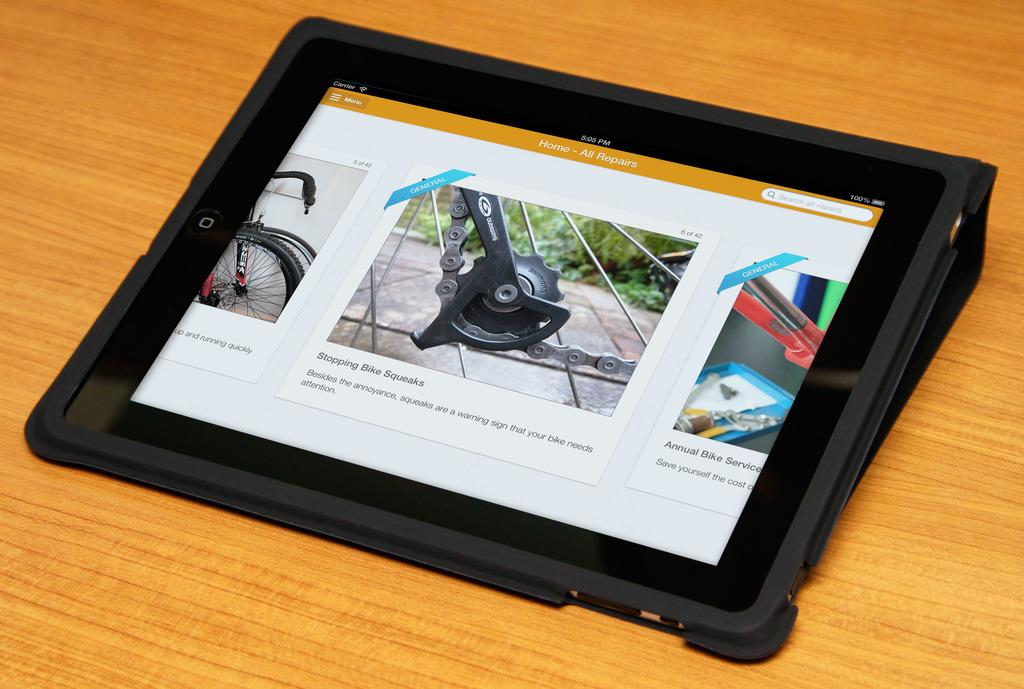What electronic device is visible in the image? There is an iPad in the image. Where is the iPad located? The iPad is on a table. What type of apples are being ordered by the committee in the image? There are no apples or committee present in the image; it only features an iPad on a table. 